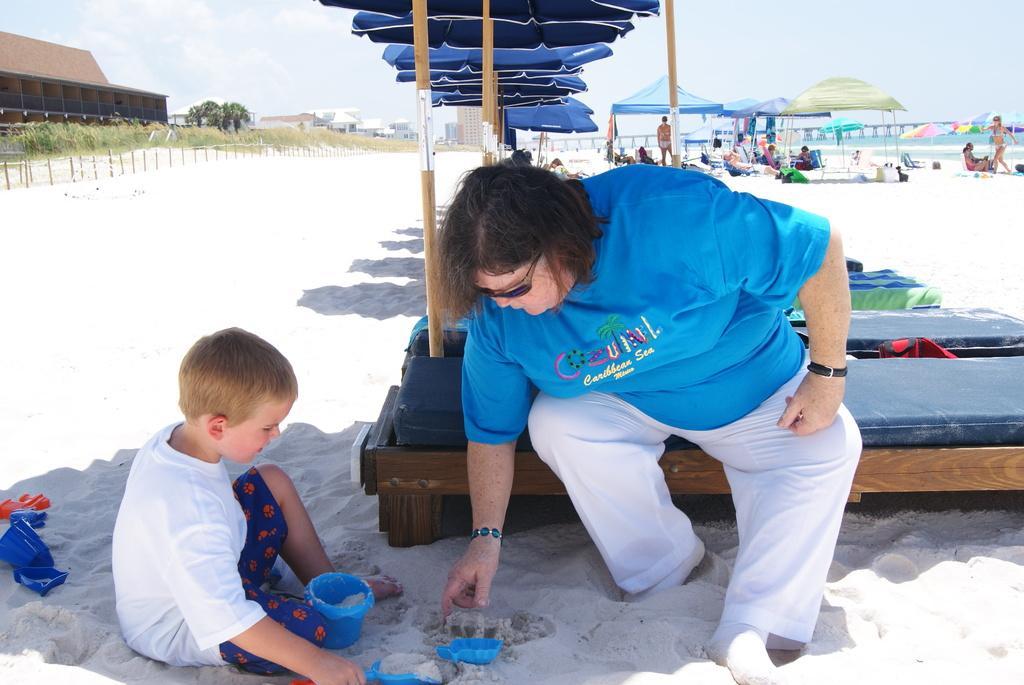How would you summarize this image in a sentence or two? This is a person sitting on the bench. These are the beach umbrellas. I can see the canopy tents. Here is a boy sitting on the sand. This looks like a small bucket, which is blue in color. This is the beach. I can see few people sitting and few people standing. These are the trees and buildings. In the background, that looks like a bridge. 